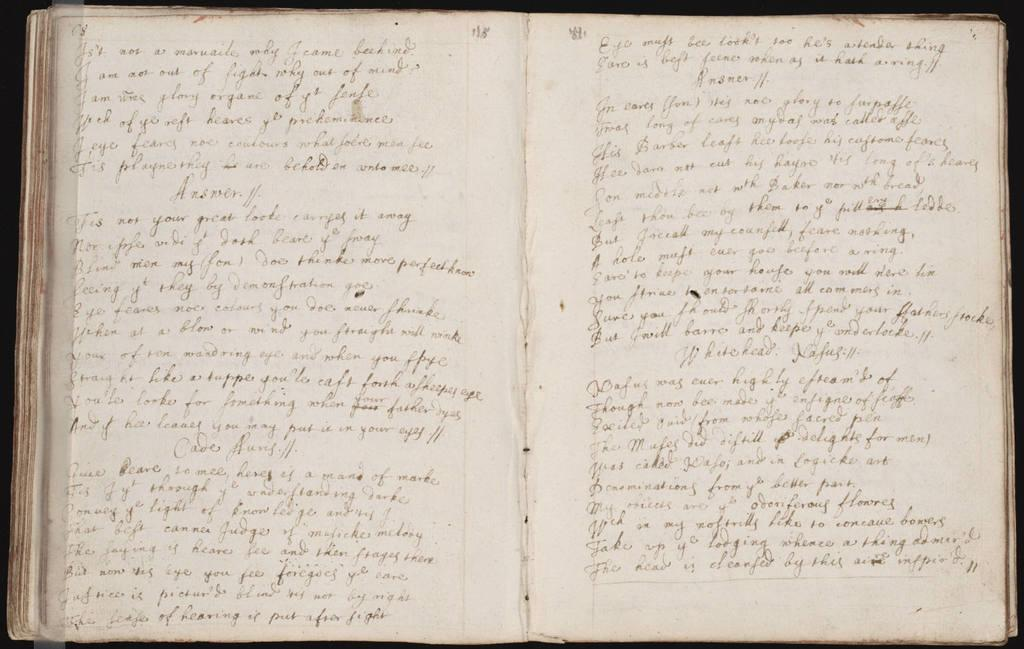What object is present in the image? There is a book in the image. What can be found on the pages of the book? The pages of the book contain text. How many toes does the book have in the image? The book does not have toes, as it is an inanimate object. 